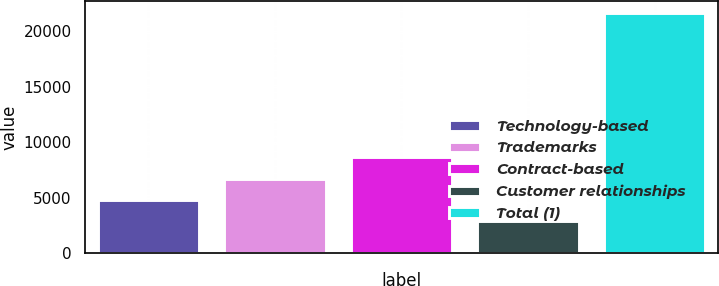<chart> <loc_0><loc_0><loc_500><loc_500><bar_chart><fcel>Technology-based<fcel>Trademarks<fcel>Contract-based<fcel>Customer relationships<fcel>Total (1)<nl><fcel>4773.9<fcel>6647.8<fcel>8650<fcel>2900<fcel>21639<nl></chart> 